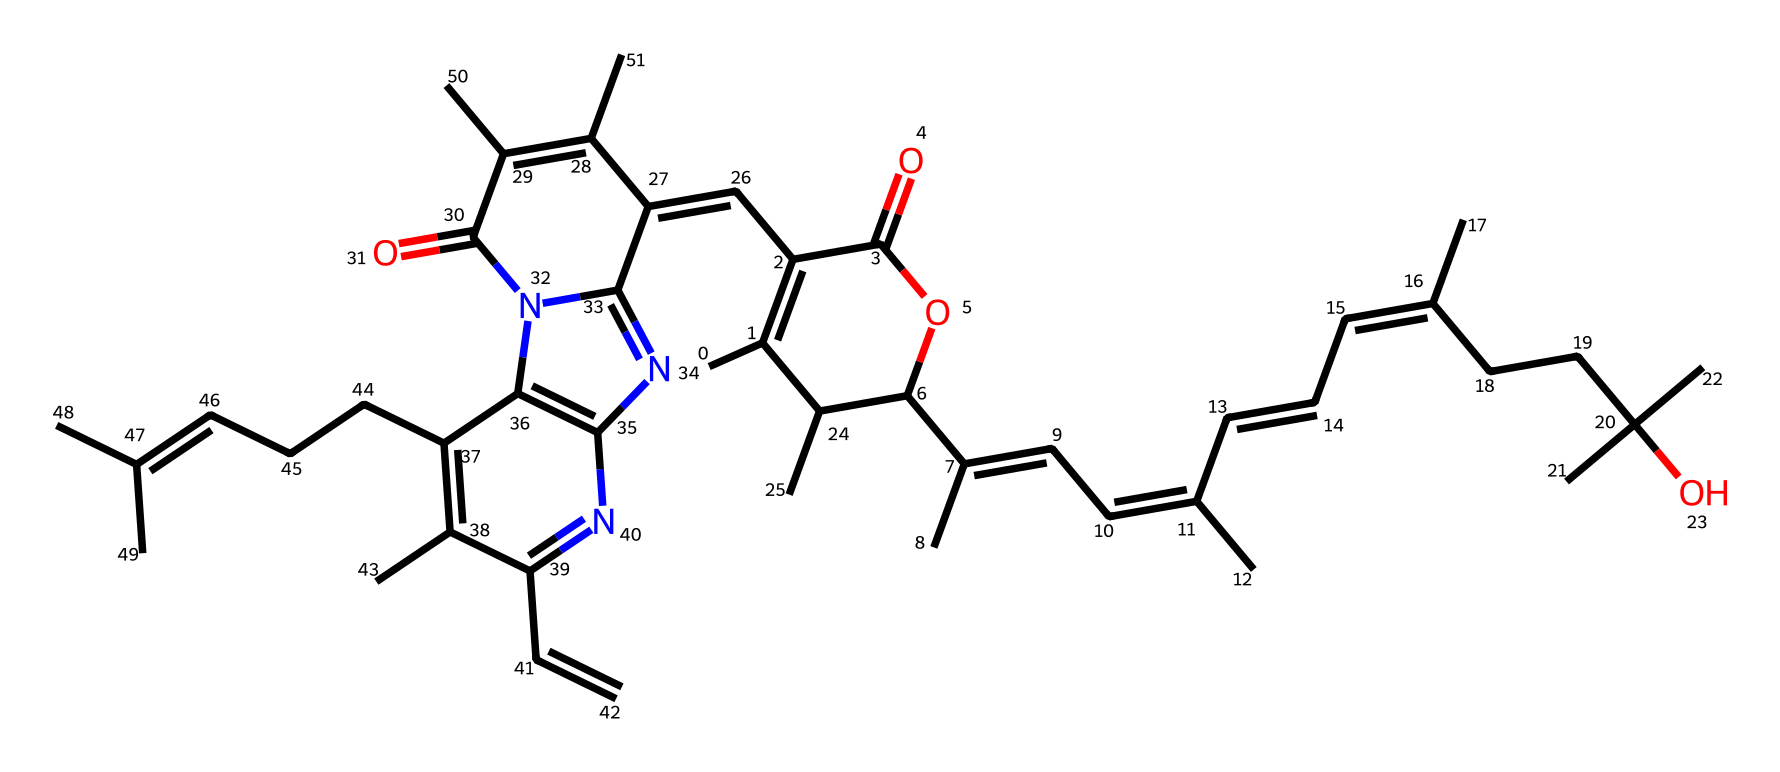What is the molecular formula of this compound? To find the molecular formula, count the different atoms in the SMILES representation. The atoms present include carbon (C), hydrogen (H), oxygen (O), and nitrogen (N). This leads to the formula C40H58N4O4 when counted correctly.
Answer: C40H58N4O4 How many rings are present in the molecular structure? By analyzing the structure, count the number of enclosed cycles or rings, which can be identified through the specific patterns in the SMILES representation. There are two ring systems detected in the compound.
Answer: 2 What is the primary functional group present in this structure? The presence of the –C(=O)O– indicates the presence of an ester functional group, which can be discerned through the specific arrangements of arms around the carbons in the SMILES.
Answer: ester What type of light could this compound absorb? Chlorophyll compounds generally absorb light in the red (around 665-680 nm) and blue (around 430-460 nm) regions, with the conjugated double bond system in its structure facilitating this absorption. This is based on the presence of conjugated systems in the structure that are typical in photoreactive compounds.
Answer: red and blue light How does the structure of this compound influence its photoreactivity? The extensive conjugated double bond system allows the compound to effectively absorb light energy. In the structure, the sequence of alternating double and single bonds (conjugation) provides the necessary electronic properties that enhance light absorption, thus contributing to its photoreactivity.
Answer: extensive conjugation What role does nitrogen play in this compound? Nitrogen contributes to the structural integrity and may influence the reactivity through nitrogen's ability to donate or accept electrons, playing a part in stabilizing the structure and possibly influencing photochemical processes.
Answer: electron contribution What is the general role of chlorophyll in historical agricultural practices? Chlorophyll is fundamental in photosynthesis, the process by which plants convert light energy into chemical energy, thus influencing crop yields and agricultural efficiency historically. Its essential function in converting sunlight is crucial for plant growth and survival.
Answer: photosynthesis 